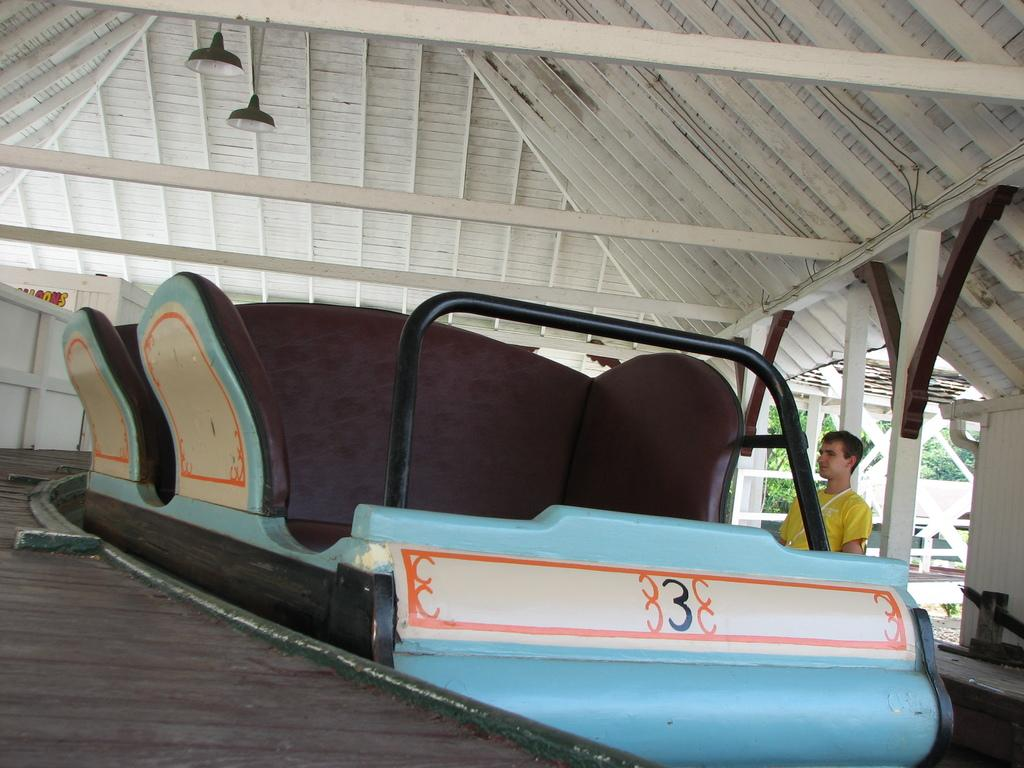What is the main object in the image? There is a ride vehicle in the image. What can be seen in the background of the image? There is a path in the image. Can you describe the person in the image? There is a person on the right side of the image. What type of illumination is present in the image? Lights are visible in the image. What provides shelter in the image? There is a wooden roof for shelter in the image. What type of natural vegetation is present in the image? Trees are present in the image. What flavor of ice cream is the person eating in the image? There is no ice cream present in the image, so it is not possible to determine the flavor. 